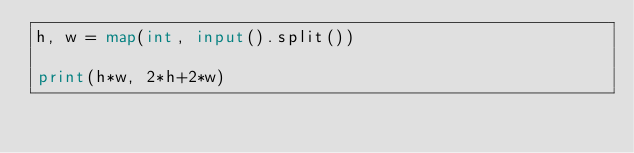<code> <loc_0><loc_0><loc_500><loc_500><_Python_>h, w = map(int, input().split())

print(h*w, 2*h+2*w)

</code> 